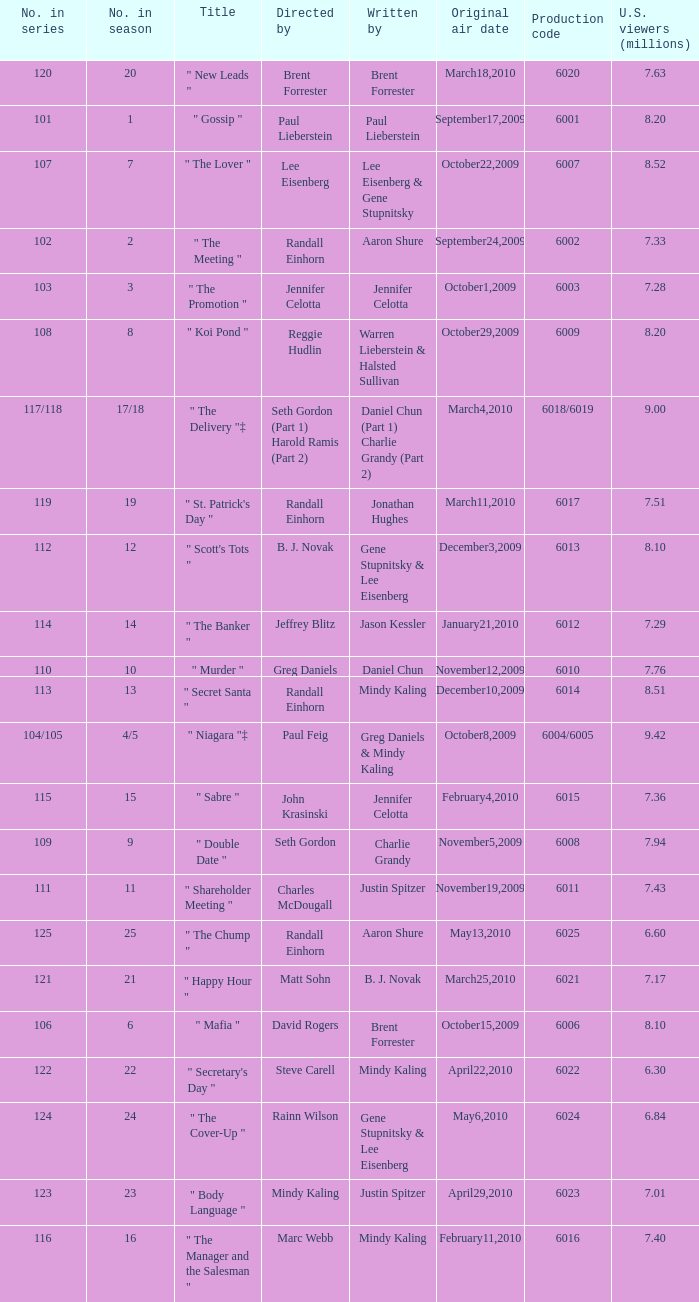Name the production code for number in season being 21 6021.0. 